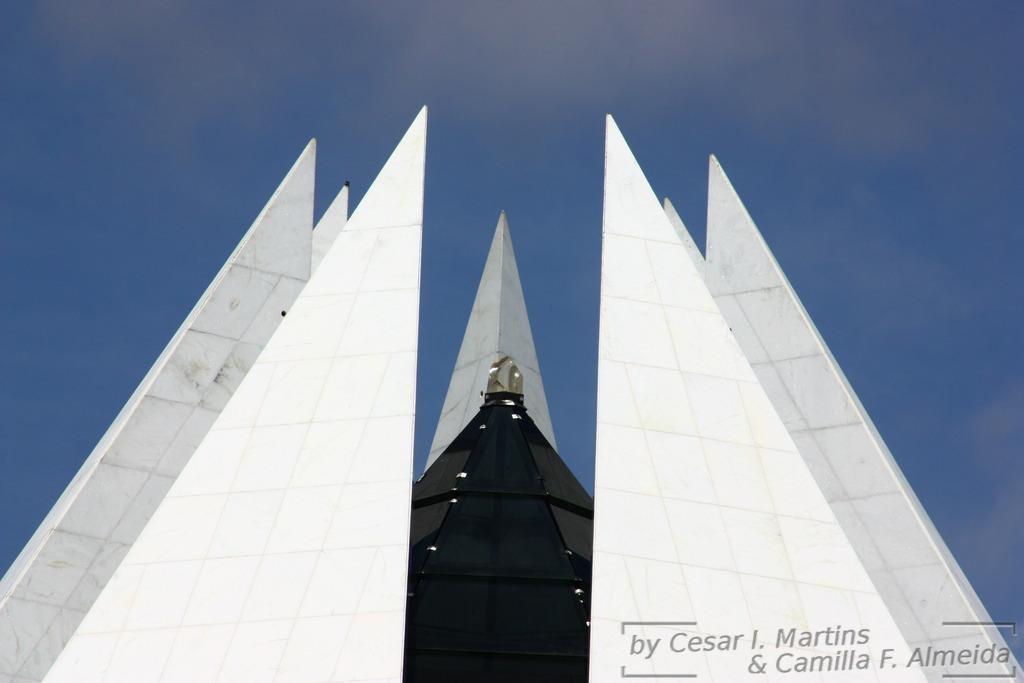Can you describe this image briefly? In this image I can see it looks like an architecture, at the top it is the sky. At the bottom there is the watermark. 